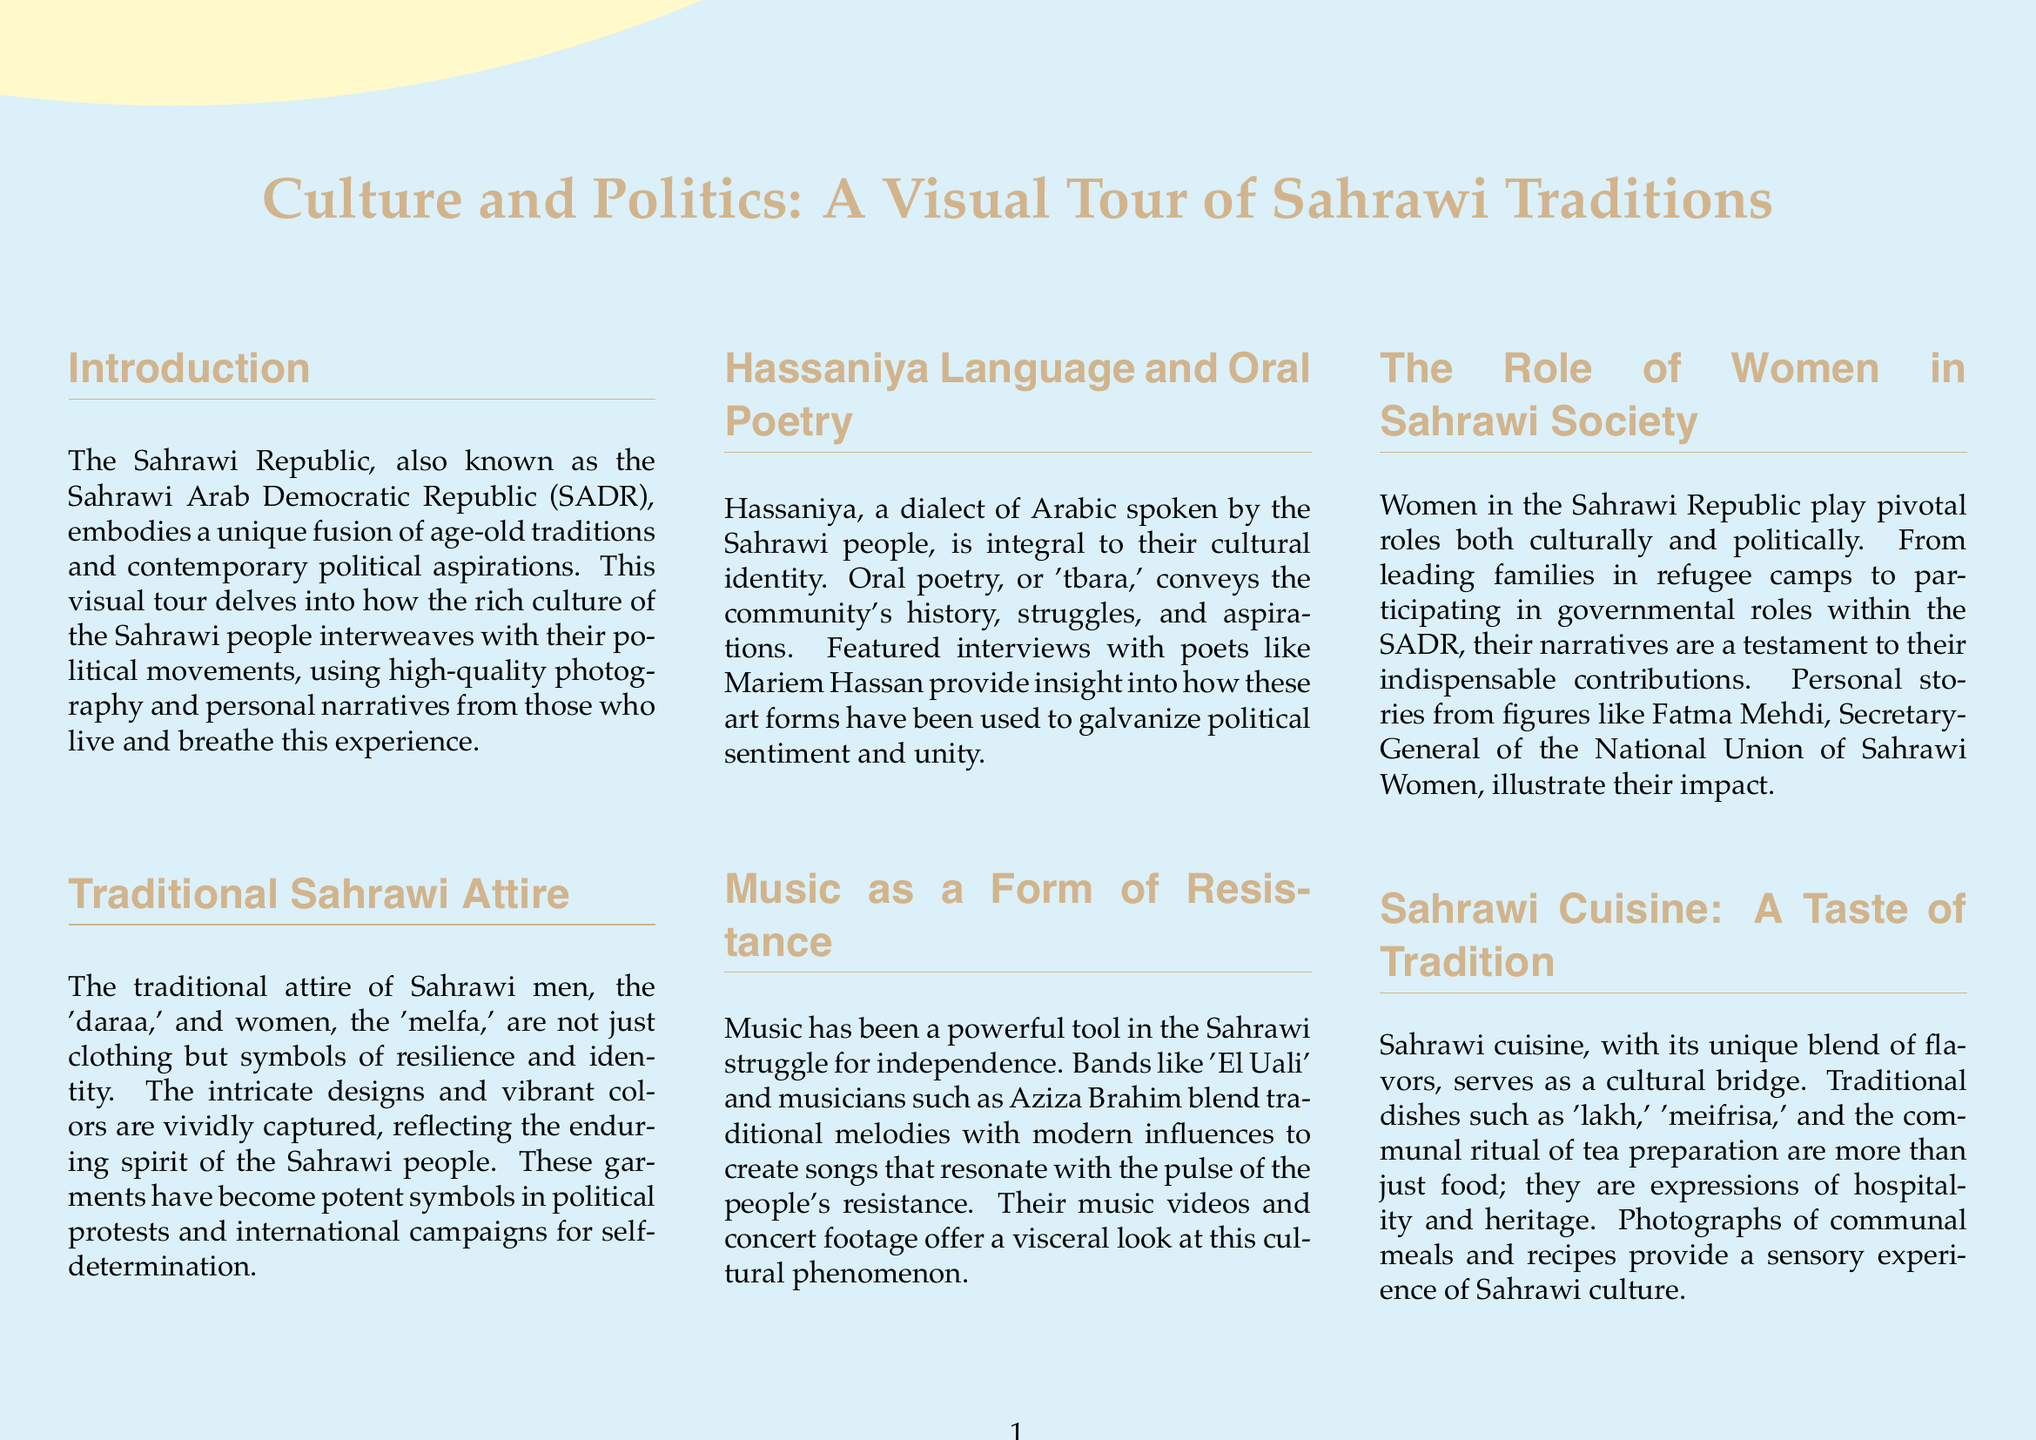what is the title of the document? The title is explicitly mentioned at the top of the document layout, which captures the main theme.
Answer: Culture and Politics: A Visual Tour of Sahrawi Traditions who is featured in the interviews about Hassaniya language? The document specifies a prominent poet who discusses the cultural significance of oral poetry, revealing insights into the language.
Answer: Mariem Hassan what is the traditional attire of women called? The specific name of the women's traditional clothing is mentioned directly, reflecting cultural identity.
Answer: melfa what is a key dish in Sahrawi cuisine? The document lists traditional food items that represent the culinary heritage of the Sahrawi people.
Answer: lakh how many sections are in the document? The document is structured in multiple sections, each focusing on different cultural aspects, which can be counted for this answer.
Answer: 6 what role do women play in Sahrawi society? The answer reflects the importance of women in cultural and political realms, as discussed in the respective section.
Answer: pivotal roles how does music function in the Sahrawi struggle? The document discusses how music serves a specific purpose in the movements, emphasizing its resistance theme.
Answer: form of resistance what is emphasized as a means to connect with the Sahrawi cause? The conclusion encourages engagement with a certain aspect of the culture to foster solidarity with the Sahrawi movement.
Answer: cultural events 